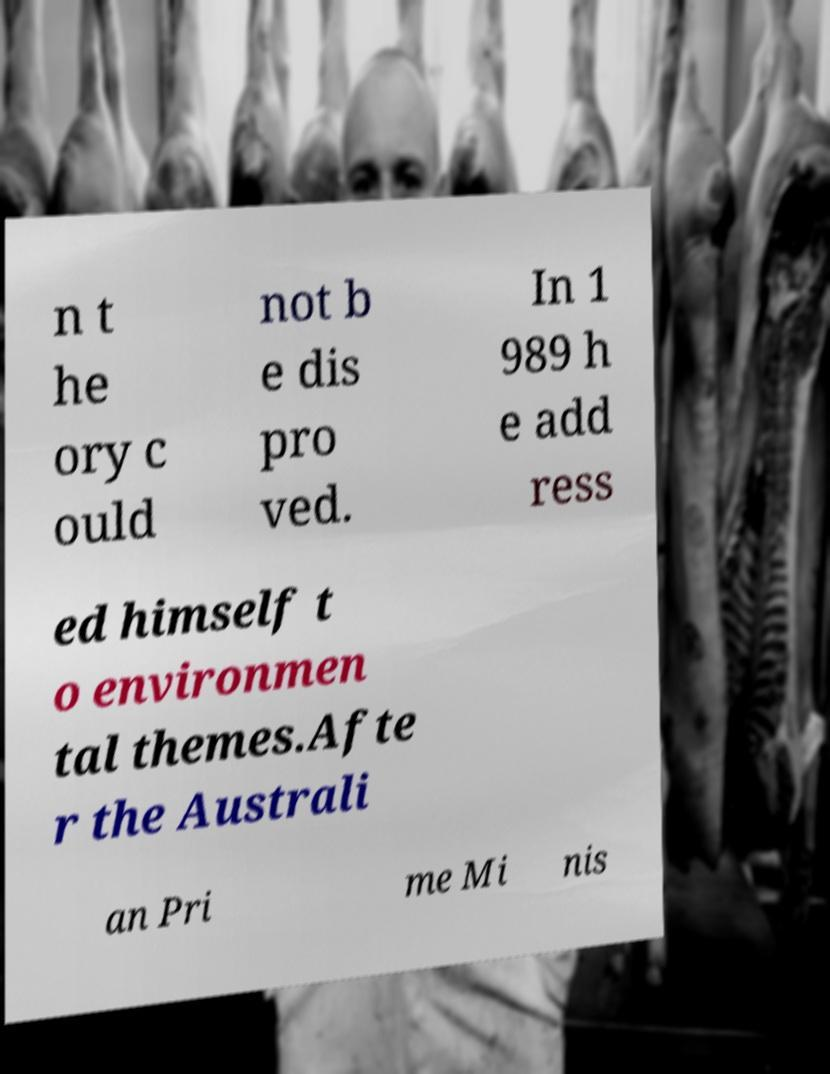I need the written content from this picture converted into text. Can you do that? n t he ory c ould not b e dis pro ved. In 1 989 h e add ress ed himself t o environmen tal themes.Afte r the Australi an Pri me Mi nis 